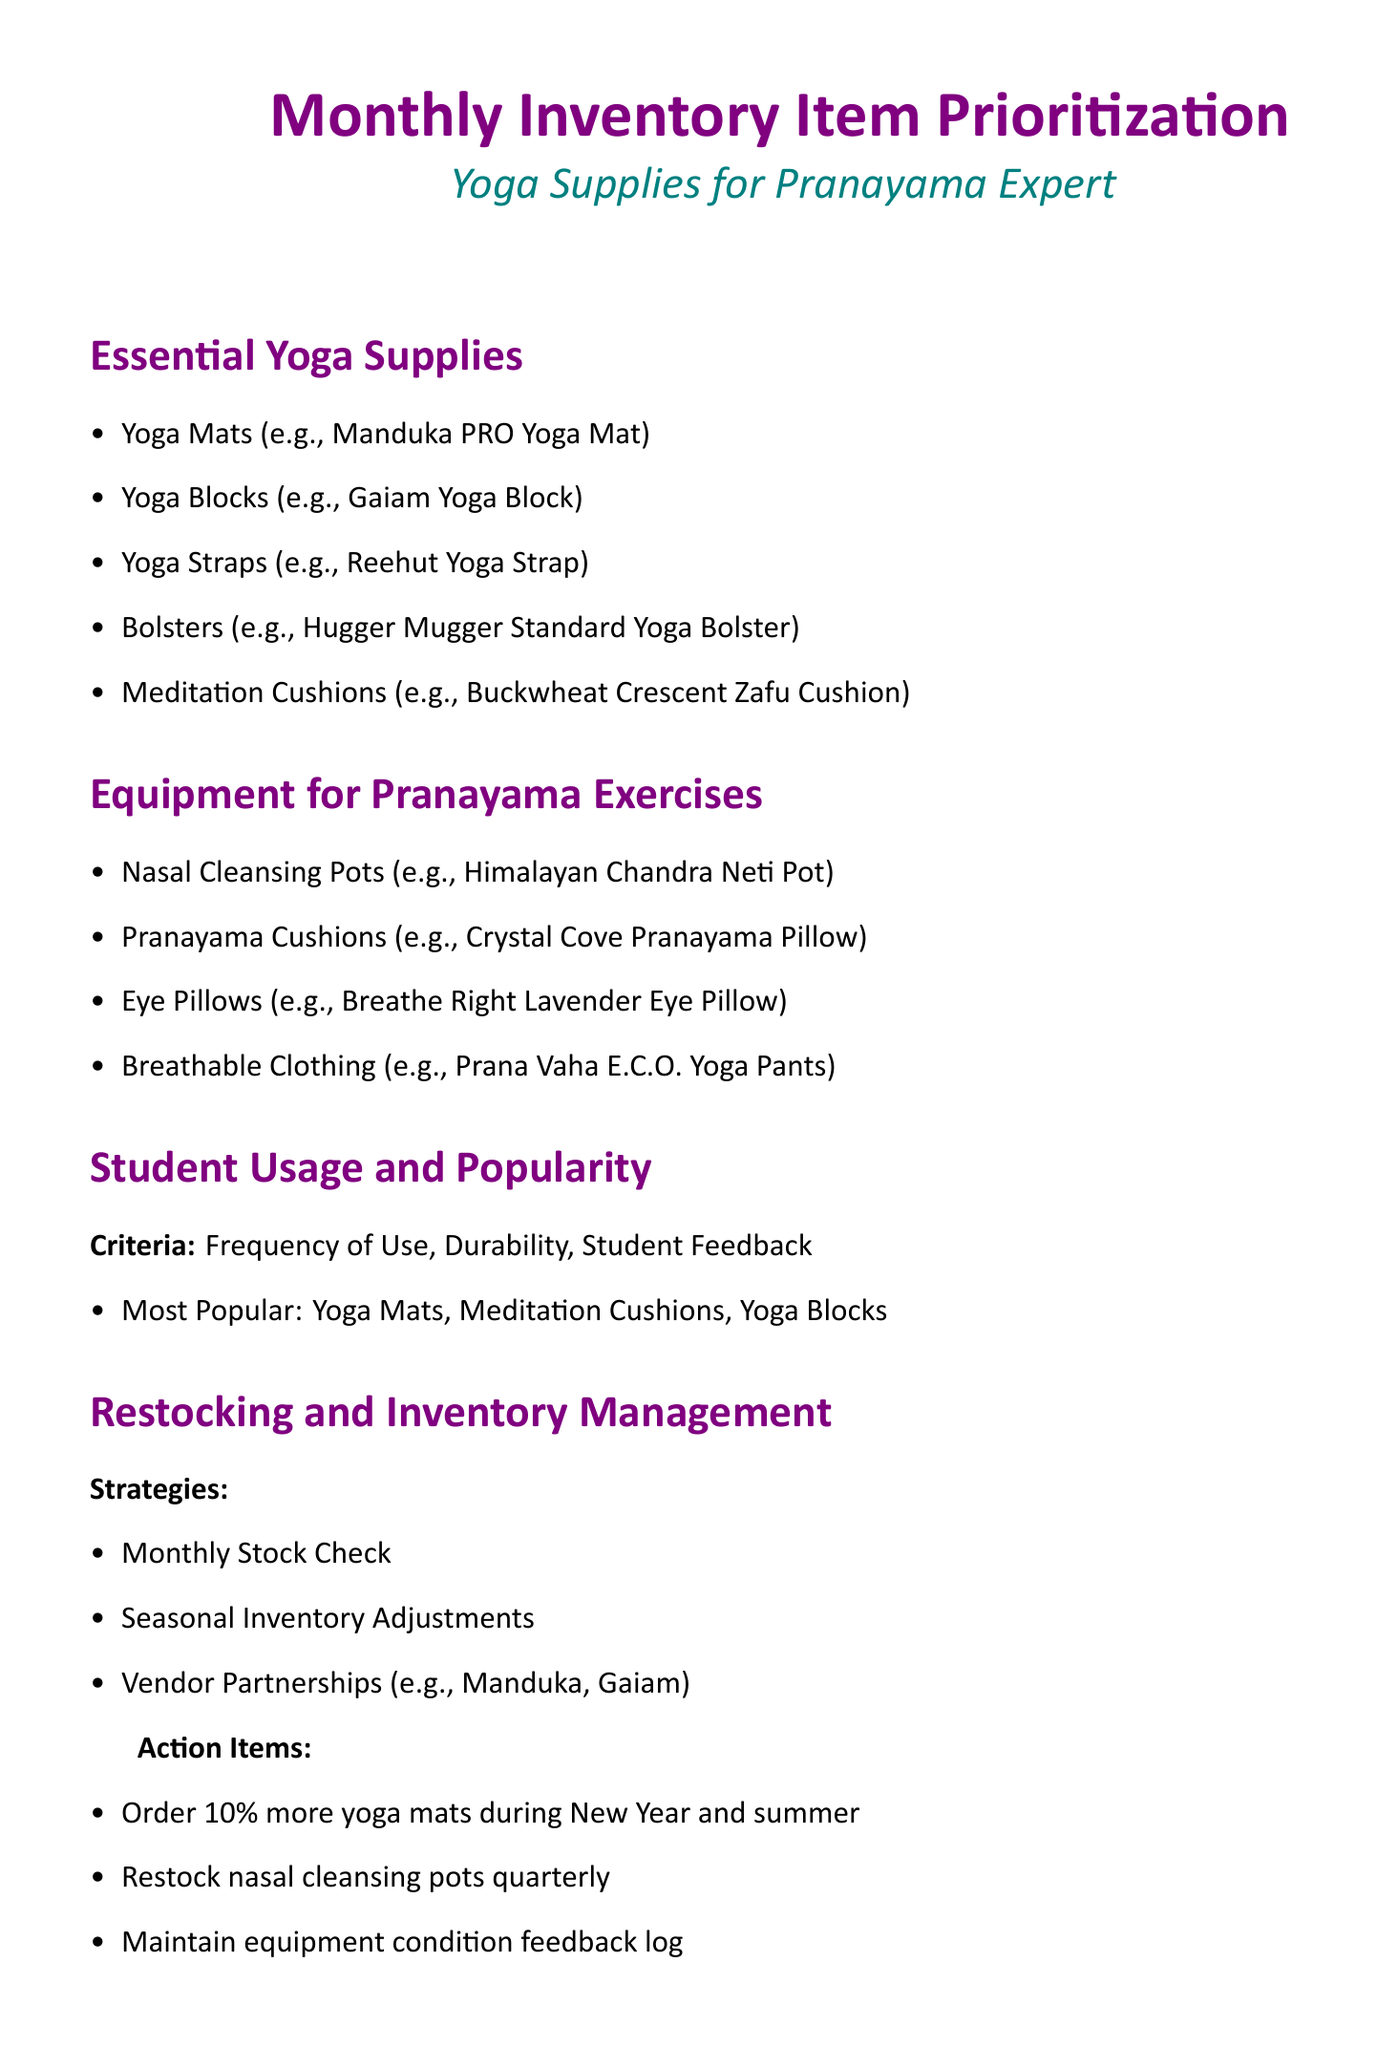what is the title of the document? The title is found at the top of the document and indicates its primary focus.
Answer: Monthly Inventory Item Prioritization which yoga mat is mentioned as an example? Specific examples of essential yoga supplies are listed in the document, and this is one such example.
Answer: Manduka PRO Yoga Mat what percentage of the budget is allocated for essential yoga supplies? The budget allocation details specify the distribution of funds for different categories.
Answer: 50% what are the most popular yoga supplies according to student feedback? The document lists items in the "Student Usage and Popularity" section based on student feedback.
Answer: Yoga Mats, Meditation Cushions, Yoga Blocks how frequently should nasal cleansing pots be restocked? The action items mention a specific timeline for restocking particular items.
Answer: Quarterly what strategy is suggested for inventory management? Several strategies are outlined for effective inventory management in the document.
Answer: Monthly Stock Check what is the color assigned for headings in the document? The document defines specific colors for various elements, including section headings.
Answer: Yogapurple which type of clothing is recommended for pranayama? The document mentions specific equipment needed for pranayama exercises, including clothing.
Answer: Breathable Clothing 